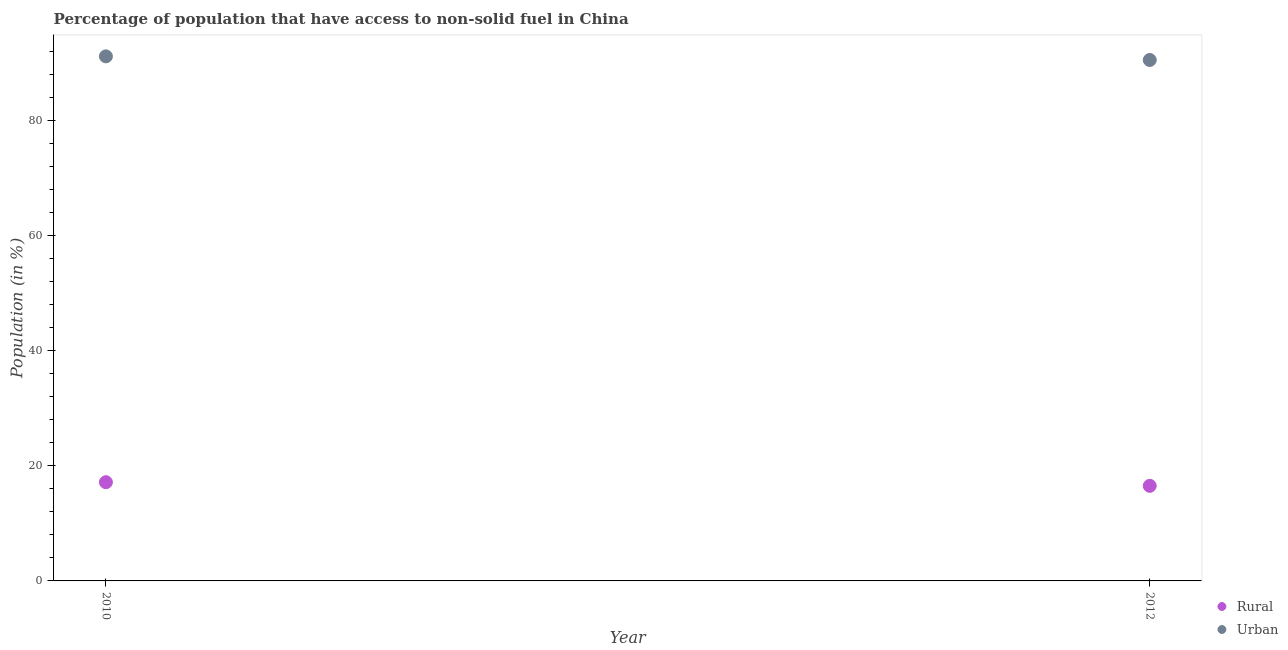What is the urban population in 2012?
Offer a very short reply. 90.57. Across all years, what is the maximum rural population?
Keep it short and to the point. 17.16. Across all years, what is the minimum rural population?
Your answer should be compact. 16.53. In which year was the rural population maximum?
Keep it short and to the point. 2010. In which year was the urban population minimum?
Offer a very short reply. 2012. What is the total rural population in the graph?
Your response must be concise. 33.69. What is the difference between the urban population in 2010 and that in 2012?
Offer a very short reply. 0.63. What is the difference between the rural population in 2010 and the urban population in 2012?
Offer a very short reply. -73.41. What is the average rural population per year?
Offer a terse response. 16.85. In the year 2012, what is the difference between the urban population and rural population?
Ensure brevity in your answer.  74.04. In how many years, is the urban population greater than 84 %?
Ensure brevity in your answer.  2. What is the ratio of the urban population in 2010 to that in 2012?
Ensure brevity in your answer.  1.01. Is the rural population in 2010 less than that in 2012?
Ensure brevity in your answer.  No. Does the rural population monotonically increase over the years?
Ensure brevity in your answer.  No. Is the urban population strictly greater than the rural population over the years?
Give a very brief answer. Yes. How many dotlines are there?
Offer a terse response. 2. How many years are there in the graph?
Offer a terse response. 2. Are the values on the major ticks of Y-axis written in scientific E-notation?
Your answer should be compact. No. Does the graph contain grids?
Provide a short and direct response. No. Where does the legend appear in the graph?
Ensure brevity in your answer.  Bottom right. How many legend labels are there?
Your response must be concise. 2. How are the legend labels stacked?
Your answer should be compact. Vertical. What is the title of the graph?
Your answer should be compact. Percentage of population that have access to non-solid fuel in China. Does "Old" appear as one of the legend labels in the graph?
Ensure brevity in your answer.  No. What is the label or title of the X-axis?
Give a very brief answer. Year. What is the Population (in %) in Rural in 2010?
Provide a short and direct response. 17.16. What is the Population (in %) of Urban in 2010?
Offer a terse response. 91.2. What is the Population (in %) of Rural in 2012?
Ensure brevity in your answer.  16.53. What is the Population (in %) of Urban in 2012?
Make the answer very short. 90.57. Across all years, what is the maximum Population (in %) in Rural?
Offer a very short reply. 17.16. Across all years, what is the maximum Population (in %) in Urban?
Your response must be concise. 91.2. Across all years, what is the minimum Population (in %) in Rural?
Your answer should be compact. 16.53. Across all years, what is the minimum Population (in %) in Urban?
Provide a short and direct response. 90.57. What is the total Population (in %) in Rural in the graph?
Your answer should be very brief. 33.69. What is the total Population (in %) in Urban in the graph?
Provide a succinct answer. 181.78. What is the difference between the Population (in %) of Rural in 2010 and that in 2012?
Ensure brevity in your answer.  0.63. What is the difference between the Population (in %) in Urban in 2010 and that in 2012?
Offer a very short reply. 0.63. What is the difference between the Population (in %) in Rural in 2010 and the Population (in %) in Urban in 2012?
Offer a terse response. -73.41. What is the average Population (in %) of Rural per year?
Give a very brief answer. 16.85. What is the average Population (in %) in Urban per year?
Give a very brief answer. 90.89. In the year 2010, what is the difference between the Population (in %) in Rural and Population (in %) in Urban?
Provide a short and direct response. -74.04. In the year 2012, what is the difference between the Population (in %) in Rural and Population (in %) in Urban?
Offer a very short reply. -74.04. What is the ratio of the Population (in %) of Rural in 2010 to that in 2012?
Make the answer very short. 1.04. What is the difference between the highest and the second highest Population (in %) in Rural?
Provide a short and direct response. 0.63. What is the difference between the highest and the second highest Population (in %) in Urban?
Offer a terse response. 0.63. What is the difference between the highest and the lowest Population (in %) in Rural?
Your response must be concise. 0.63. What is the difference between the highest and the lowest Population (in %) in Urban?
Ensure brevity in your answer.  0.63. 